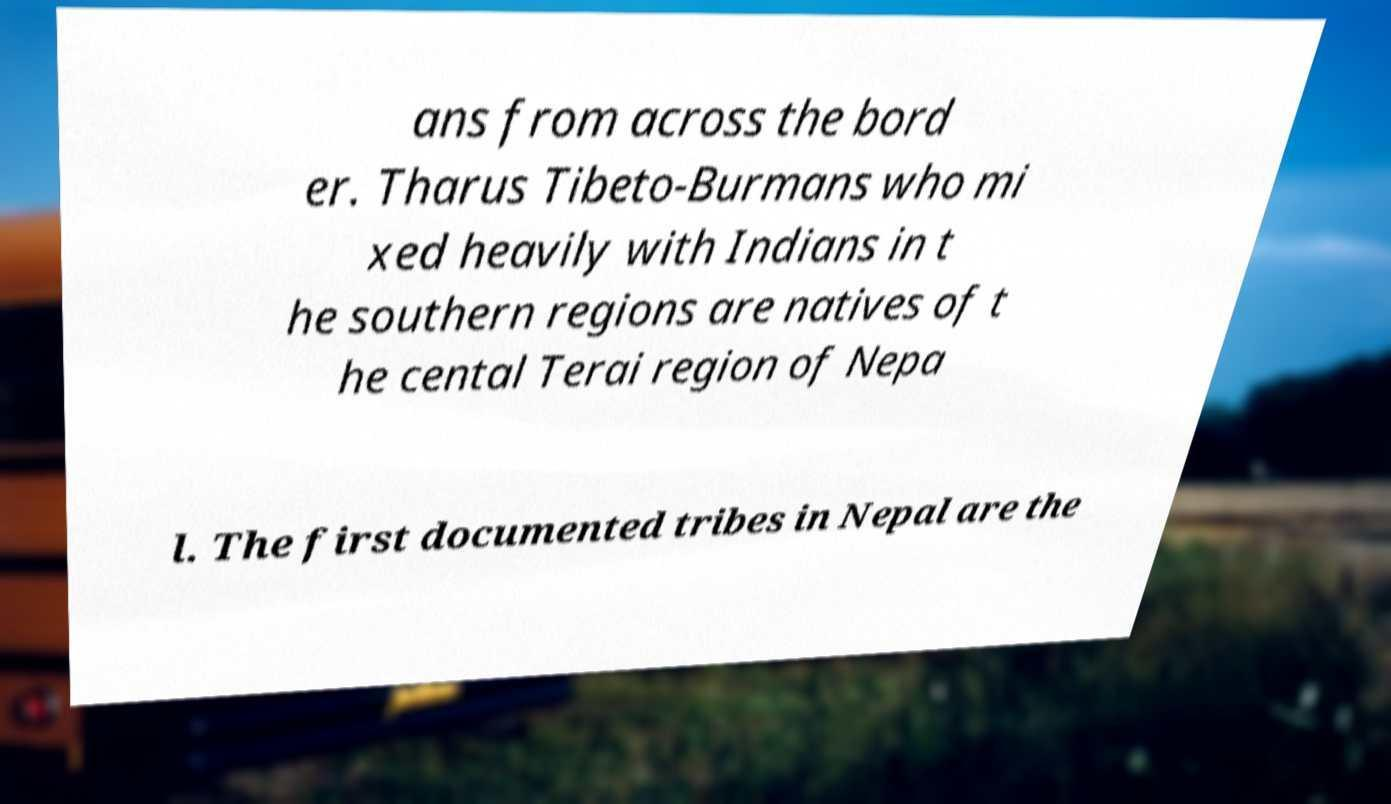What messages or text are displayed in this image? I need them in a readable, typed format. ans from across the bord er. Tharus Tibeto-Burmans who mi xed heavily with Indians in t he southern regions are natives of t he cental Terai region of Nepa l. The first documented tribes in Nepal are the 